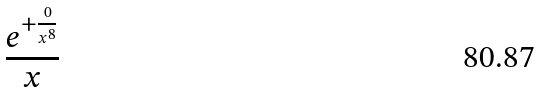<formula> <loc_0><loc_0><loc_500><loc_500>\frac { e ^ { + \frac { 0 } { x ^ { 8 } } } } { x }</formula> 